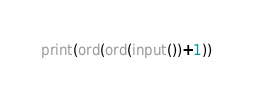<code> <loc_0><loc_0><loc_500><loc_500><_Python_>print(ord(ord(input())+1))</code> 